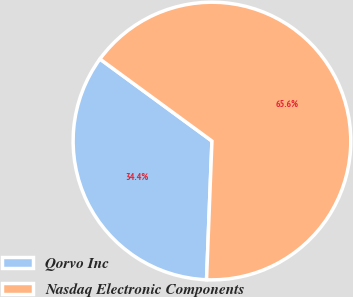Convert chart to OTSL. <chart><loc_0><loc_0><loc_500><loc_500><pie_chart><fcel>Qorvo Inc<fcel>Nasdaq Electronic Components<nl><fcel>34.44%<fcel>65.56%<nl></chart> 